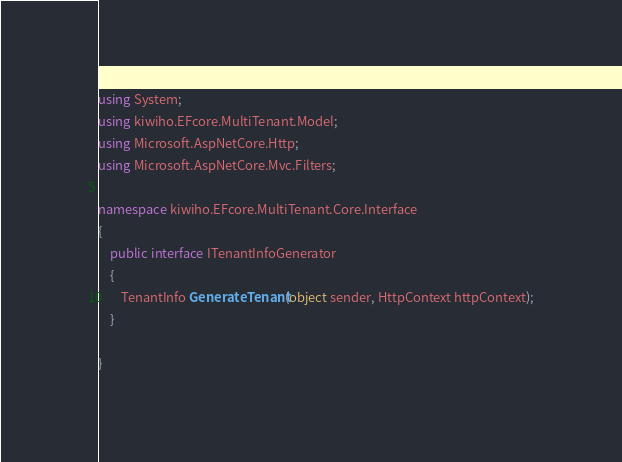Convert code to text. <code><loc_0><loc_0><loc_500><loc_500><_C#_>using System;
using kiwiho.EFcore.MultiTenant.Model;
using Microsoft.AspNetCore.Http;
using Microsoft.AspNetCore.Mvc.Filters;

namespace kiwiho.EFcore.MultiTenant.Core.Interface
{
    public interface ITenantInfoGenerator
    {
        TenantInfo GenerateTenant(object sender, HttpContext httpContext);
    }

}
</code> 